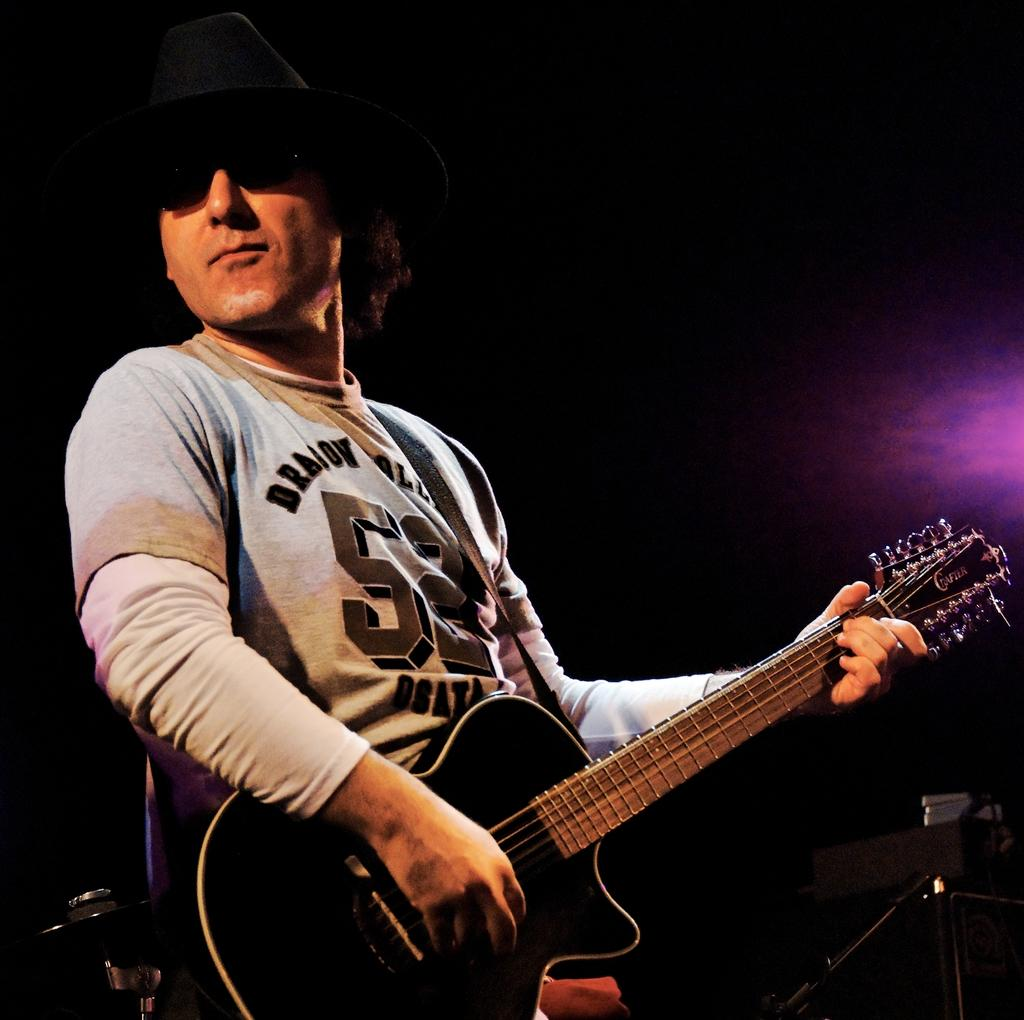What is the man in the image doing? The man is playing the guitar. What object is the man holding in the image? The man is holding a guitar. What accessories is the man wearing in the image? The man is wearing a hat and goggles. What is the color of the man's T-shirt in the image? The man is wearing a white T-shirt with some design. What is the lighting condition in the image? The background of the image is dark. How does the man's lip sync to the music in the image? There is no indication in the image that the man is lip syncing to music; he is simply playing the guitar. 